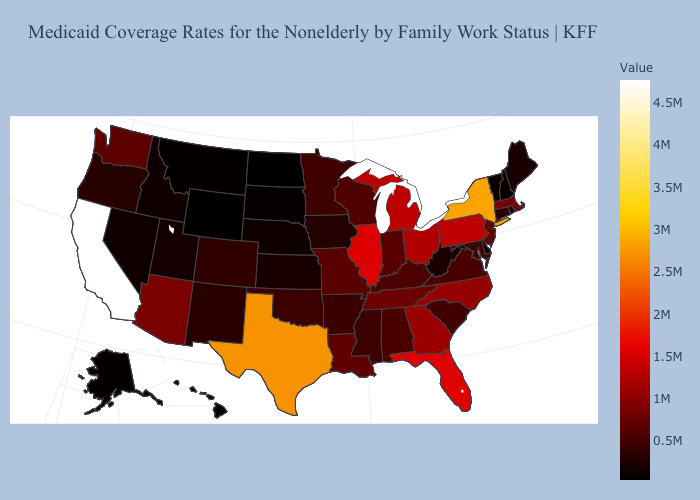Does California have the highest value in the USA?
Concise answer only. Yes. Among the states that border Mississippi , which have the lowest value?
Give a very brief answer. Arkansas. Is the legend a continuous bar?
Give a very brief answer. Yes. 